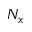Convert formula to latex. <formula><loc_0><loc_0><loc_500><loc_500>N _ { x }</formula> 